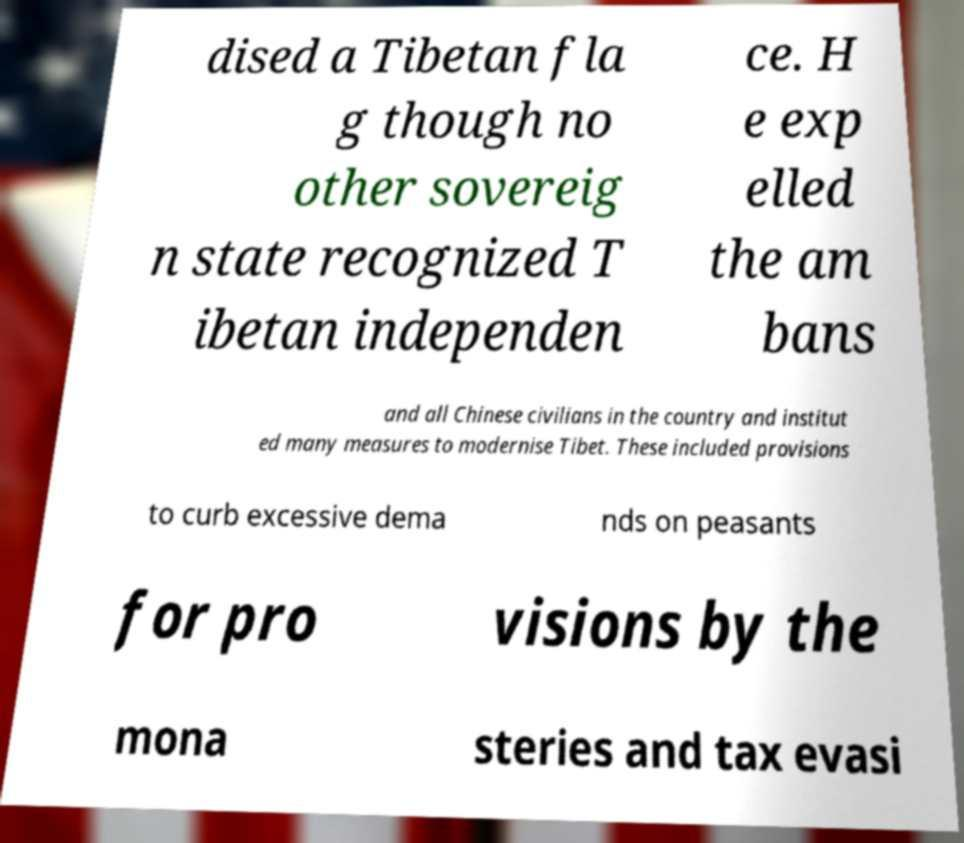What messages or text are displayed in this image? I need them in a readable, typed format. dised a Tibetan fla g though no other sovereig n state recognized T ibetan independen ce. H e exp elled the am bans and all Chinese civilians in the country and institut ed many measures to modernise Tibet. These included provisions to curb excessive dema nds on peasants for pro visions by the mona steries and tax evasi 